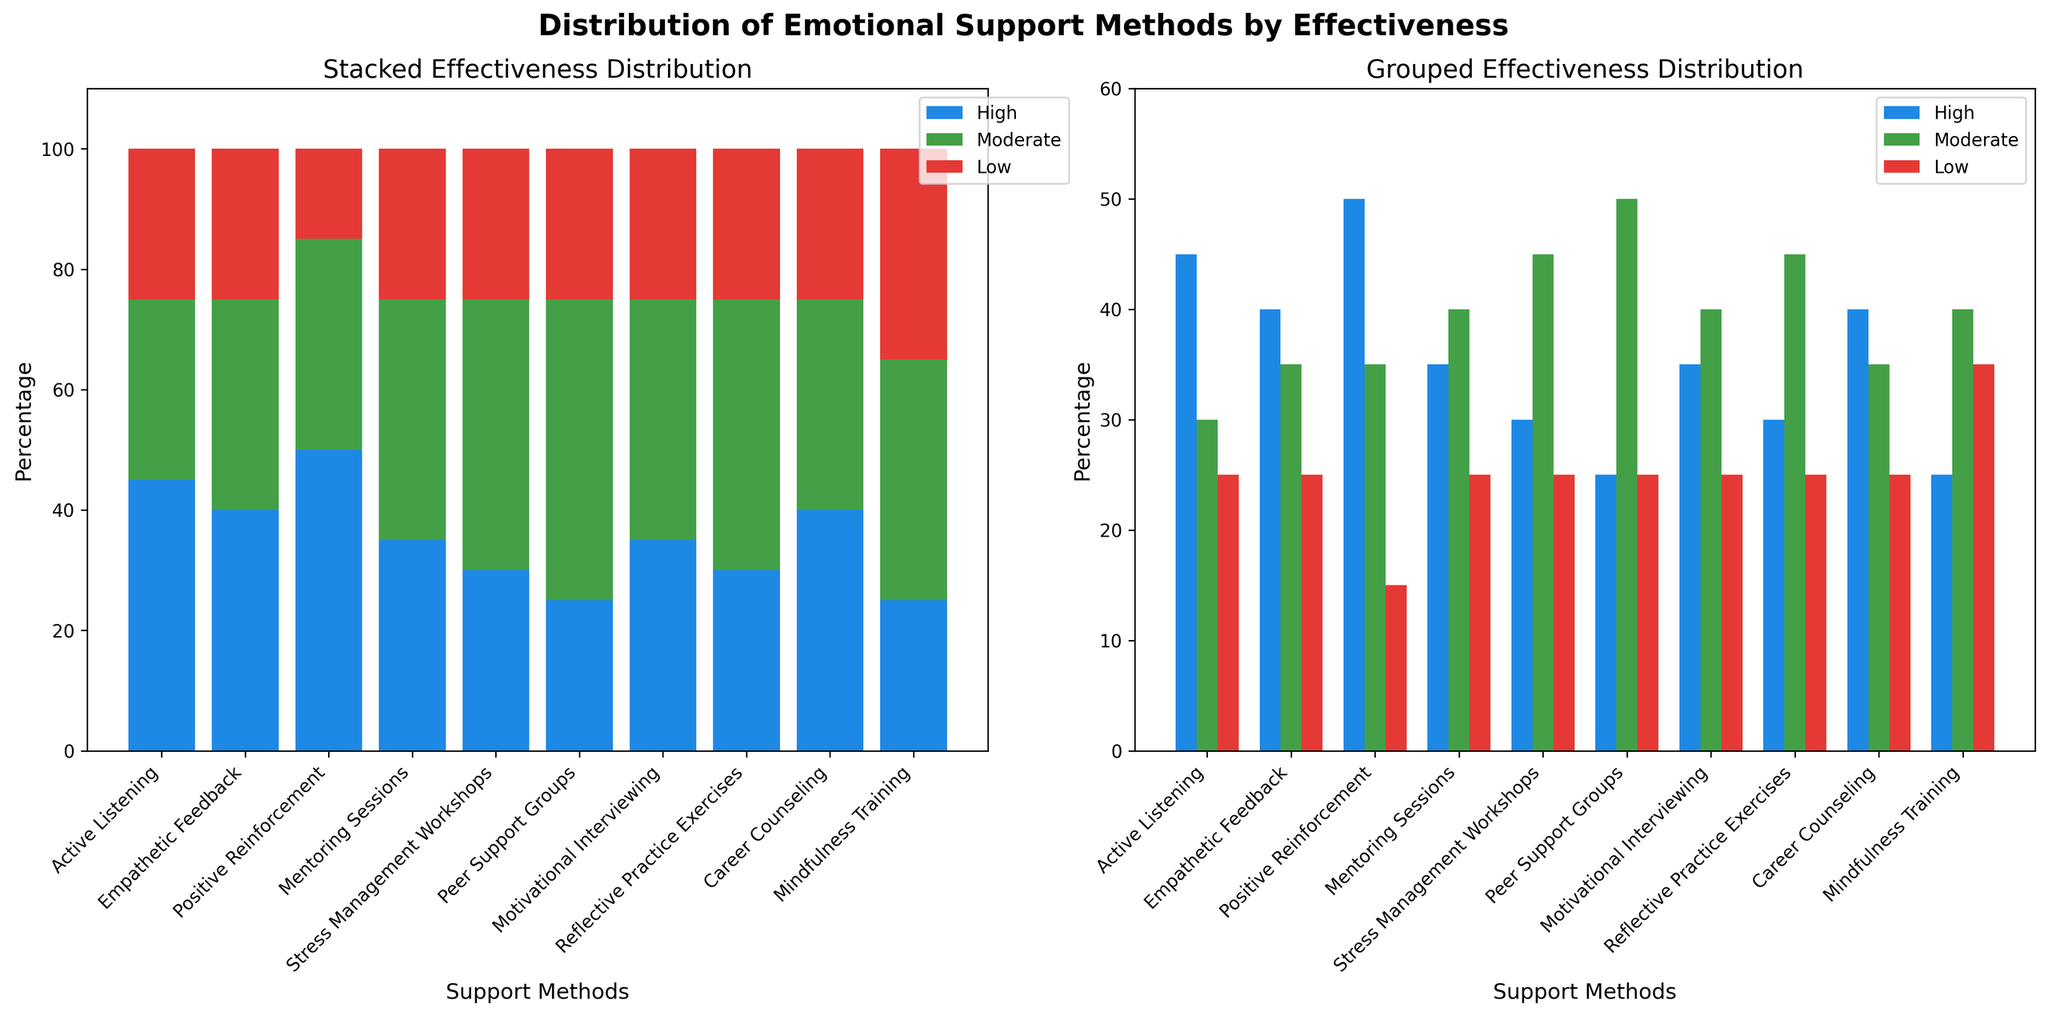What is the title of the figure? The title is displayed at the top center of the figure and reads 'Distribution of Emotional Support Methods by Effectiveness'.
Answer: Distribution of Emotional Support Methods by Effectiveness Which support method has the highest 'High Effectiveness' percentage? Looking at both subplots, 'Positive Reinforcement' has the tallest blue bar in the 'High Effectiveness' category.
Answer: Positive Reinforcement Which effectiveness category is most frequent for 'Mindfulness Training'? Observing the grouped or stacked bar chart, 'Moderate Effectiveness' has the tallest green bar for 'Mindfulness Training'.
Answer: Moderate Effectiveness What is the total percentage represented for 'Stress Management Workshops' across all effectiveness levels? Adding up the 'High', 'Moderate', and 'Low' percentages for 'Stress Management Workshops' gives 30 + 45 + 25 = 100%.
Answer: 100% Compare 'Active Listening' and 'Peer Support Groups' in terms of 'Low Effectiveness'. Which method has a higher percentage? In the bar charts, both methods show the same height of the red bars for 'Low Effectiveness', indicating they have equal percentages.
Answer: Equal Which support method shows the lowest percentage of 'High Effectiveness'? The shortest blue bar in the 'High Effectiveness' category is for 'Mindfulness Training', showing the lowest percentage.
Answer: Mindfulness Training How many support methods have equal 'High Effectiveness' and 'Moderate Effectiveness' percentages? Analyzing the bar heights in both charts, no support method has equal 'High' and 'Moderate Effectiveness' percentages.
Answer: None What is the average percentage of 'High Effectiveness' for all support methods? Summing the 'High Effectiveness' values (45 + 40 + 50 + 35 + 30 + 25 + 35 + 30 + 40 + 25) gives 355, and dividing by the number of methods (10) results in an average of 35.5%.
Answer: 35.5% Which method has the second highest 'Moderate Effectiveness' percentage? After 'Peer Support Groups' with the tallest green bar, 'Stress Management Workshops' has the next tallest green bar for 'Moderate Effectiveness'.
Answer: Stress Management Workshops What is the proportion of 'Low Effectiveness' to 'High Effectiveness' for 'Career Counseling'? For 'Career Counseling', the 'Low Effectiveness' is 25 and 'High Effectiveness' is 40. The proportion of 'Low' to 'High' is 25/40, which simplifies to 0.625.
Answer: 0.625 